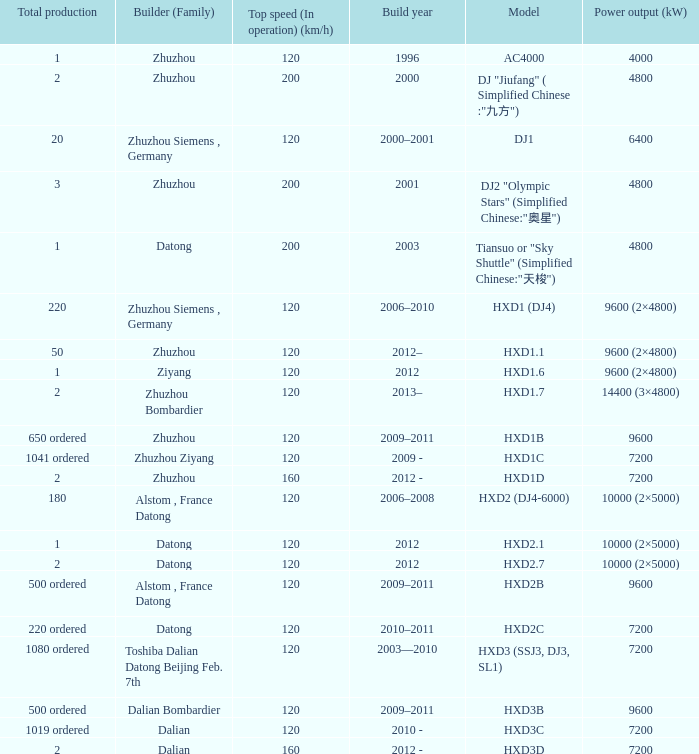What is the power output (kw) of model hxd3d? 7200.0. Parse the full table. {'header': ['Total production', 'Builder (Family)', 'Top speed (In operation) (km/h)', 'Build year', 'Model', 'Power output (kW)'], 'rows': [['1', 'Zhuzhou', '120', '1996', 'AC4000', '4000'], ['2', 'Zhuzhou', '200', '2000', 'DJ "Jiufang" ( Simplified Chinese :"九方")', '4800'], ['20', 'Zhuzhou Siemens , Germany', '120', '2000–2001', 'DJ1', '6400'], ['3', 'Zhuzhou', '200', '2001', 'DJ2 "Olympic Stars" (Simplified Chinese:"奥星")', '4800'], ['1', 'Datong', '200', '2003', 'Tiansuo or "Sky Shuttle" (Simplified Chinese:"天梭")', '4800'], ['220', 'Zhuzhou Siemens , Germany', '120', '2006–2010', 'HXD1 (DJ4)', '9600 (2×4800)'], ['50', 'Zhuzhou', '120', '2012–', 'HXD1.1', '9600 (2×4800)'], ['1', 'Ziyang', '120', '2012', 'HXD1.6', '9600 (2×4800)'], ['2', 'Zhuzhou Bombardier', '120', '2013–', 'HXD1.7', '14400 (3×4800)'], ['650 ordered', 'Zhuzhou', '120', '2009–2011', 'HXD1B', '9600'], ['1041 ordered', 'Zhuzhou Ziyang', '120', '2009 -', 'HXD1C', '7200'], ['2', 'Zhuzhou', '160', '2012 -', 'HXD1D', '7200'], ['180', 'Alstom , France Datong', '120', '2006–2008', 'HXD2 (DJ4-6000)', '10000 (2×5000)'], ['1', 'Datong', '120', '2012', 'HXD2.1', '10000 (2×5000)'], ['2', 'Datong', '120', '2012', 'HXD2.7', '10000 (2×5000)'], ['500 ordered', 'Alstom , France Datong', '120', '2009–2011', 'HXD2B', '9600'], ['220 ordered', 'Datong', '120', '2010–2011', 'HXD2C', '7200'], ['1080 ordered', 'Toshiba Dalian Datong Beijing Feb. 7th', '120', '2003—2010', 'HXD3 (SSJ3, DJ3, SL1)', '7200'], ['500 ordered', 'Dalian Bombardier', '120', '2009–2011', 'HXD3B', '9600'], ['1019 ordered', 'Dalian', '120', '2010 -', 'HXD3C', '7200'], ['2', 'Dalian', '160', '2012 -', 'HXD3D', '7200']]} 